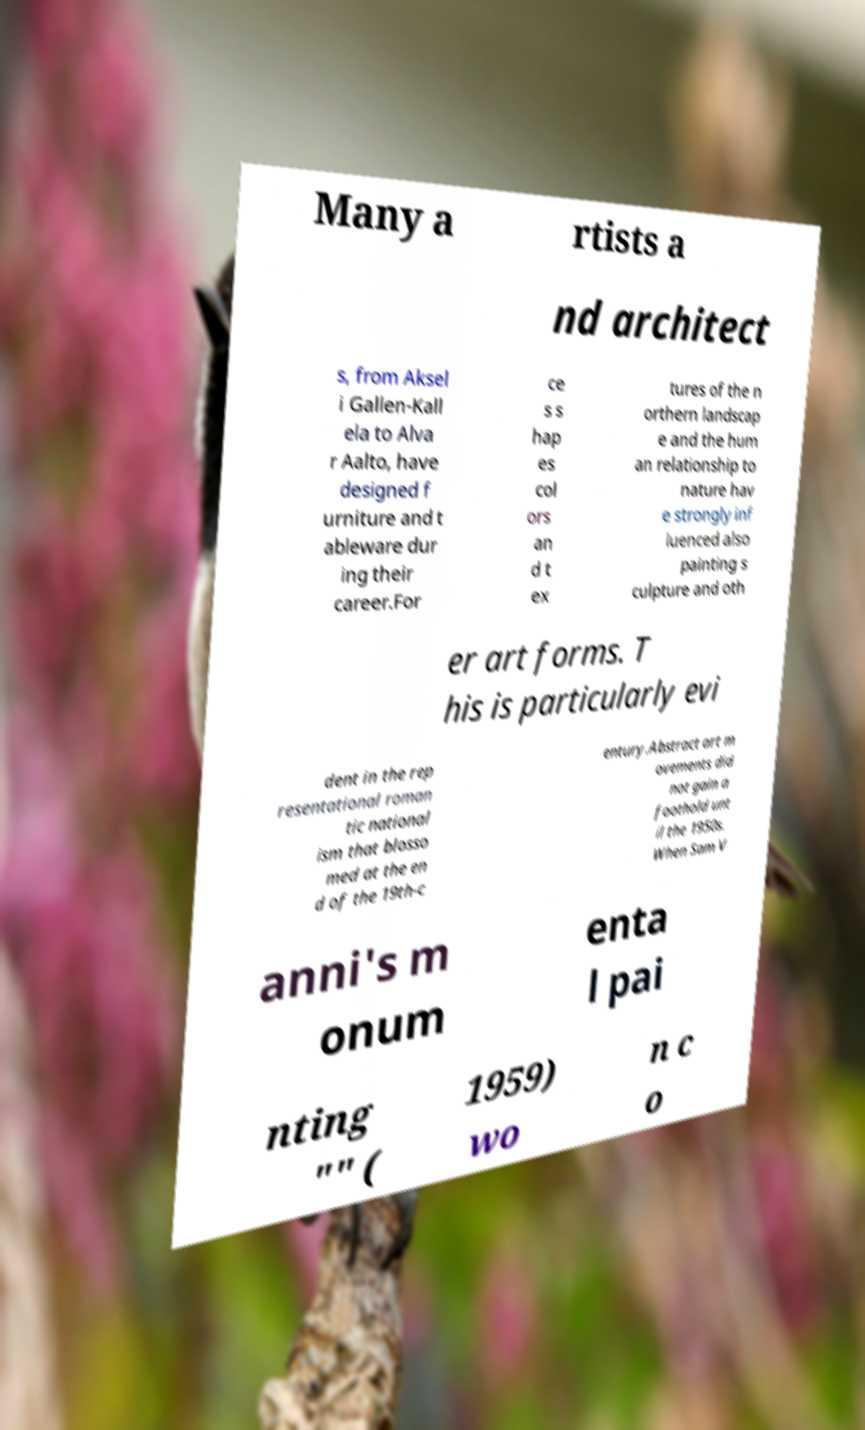I need the written content from this picture converted into text. Can you do that? Many a rtists a nd architect s, from Aksel i Gallen-Kall ela to Alva r Aalto, have designed f urniture and t ableware dur ing their career.For ce s s hap es col ors an d t ex tures of the n orthern landscap e and the hum an relationship to nature hav e strongly inf luenced also painting s culpture and oth er art forms. T his is particularly evi dent in the rep resentational roman tic national ism that blosso med at the en d of the 19th-c entury.Abstract art m ovements did not gain a foothold unt il the 1950s. When Sam V anni's m onum enta l pai nting "" ( 1959) wo n c o 